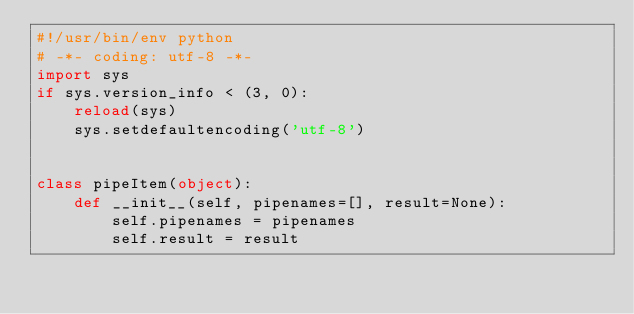Convert code to text. <code><loc_0><loc_0><loc_500><loc_500><_Python_>#!/usr/bin/env python
# -*- coding: utf-8 -*-
import sys
if sys.version_info < (3, 0):
    reload(sys)
    sys.setdefaultencoding('utf-8')


class pipeItem(object):
    def __init__(self, pipenames=[], result=None):
        self.pipenames = pipenames
        self.result = result
</code> 